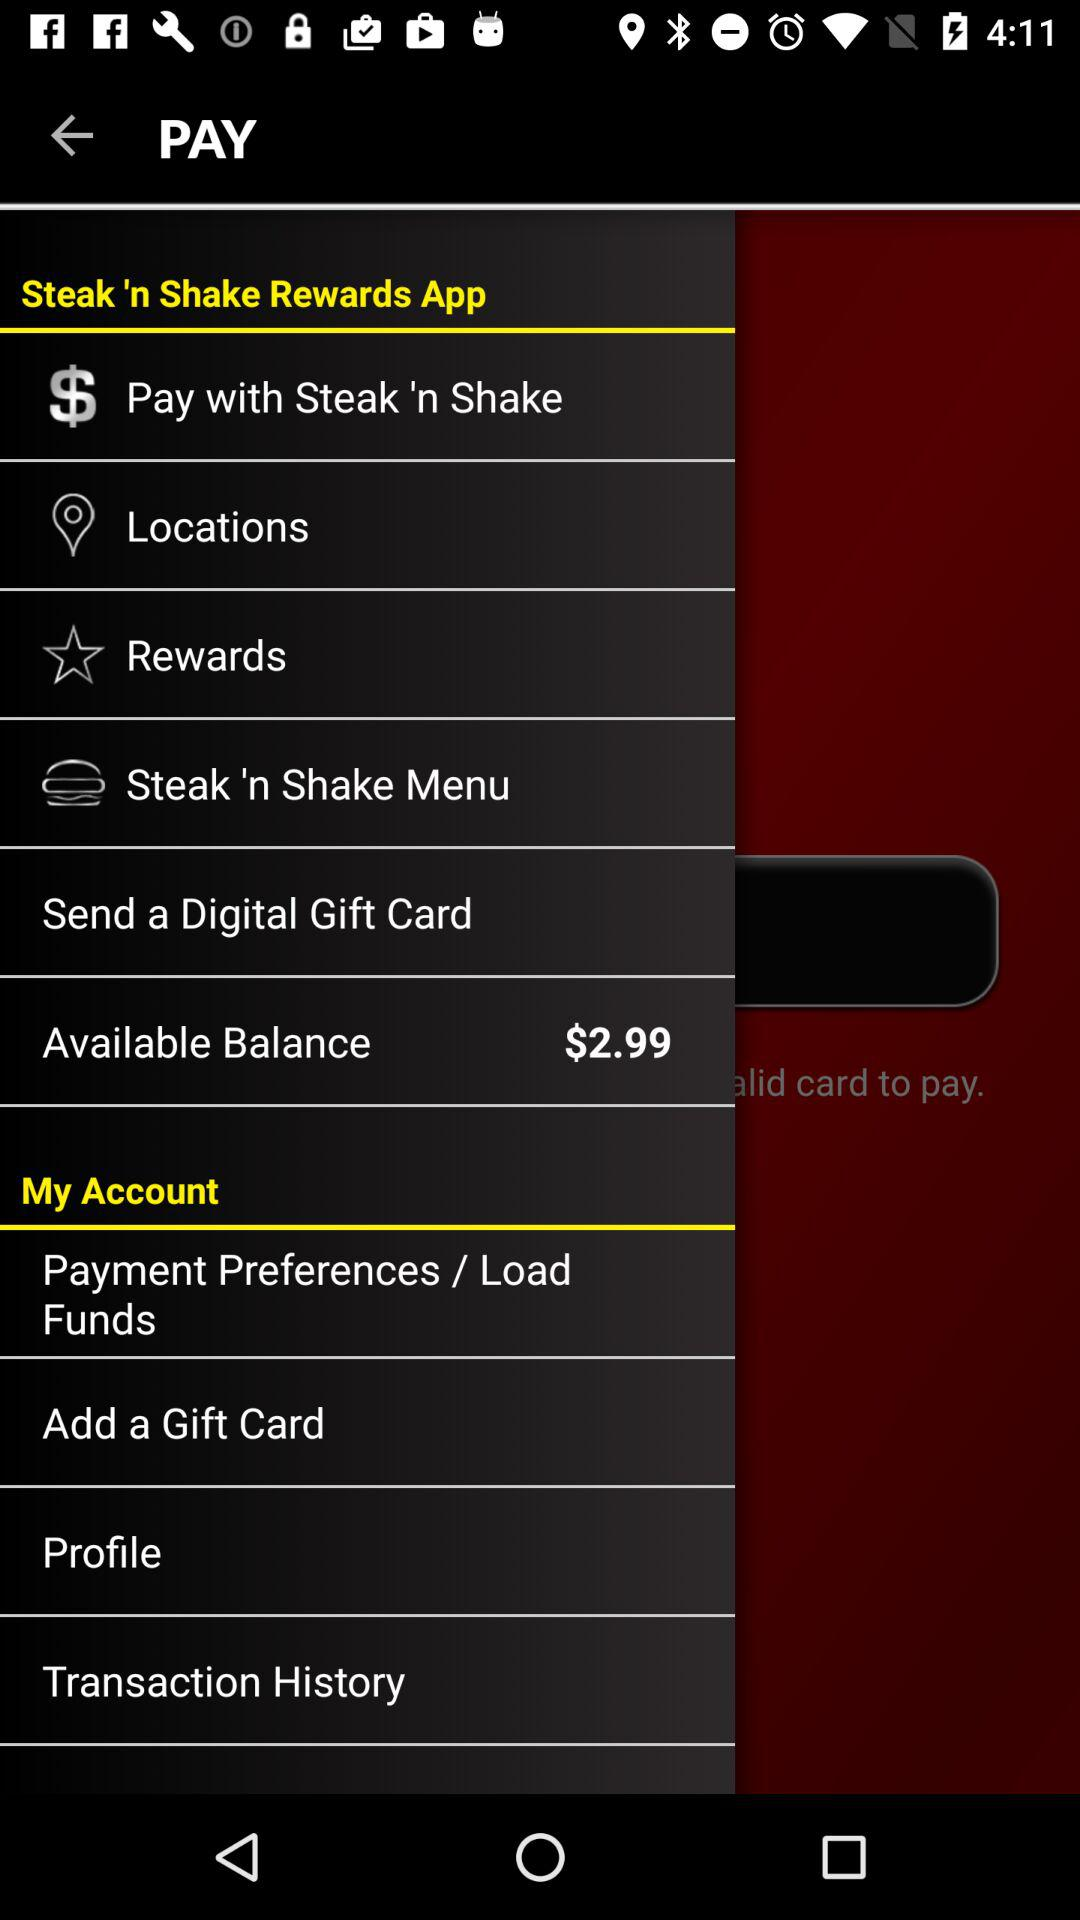What is the available balance? The available balance is $2.99. 